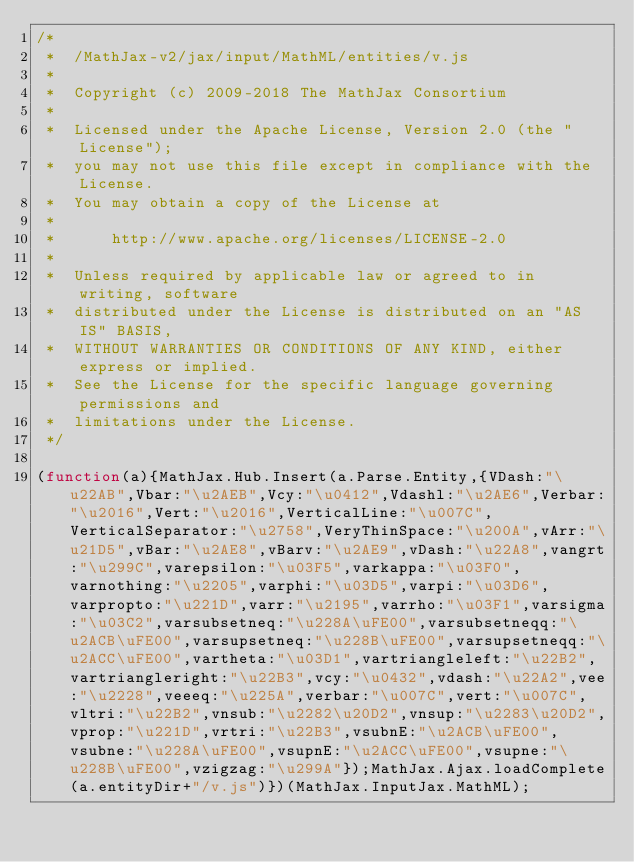Convert code to text. <code><loc_0><loc_0><loc_500><loc_500><_JavaScript_>/*
 *  /MathJax-v2/jax/input/MathML/entities/v.js
 *
 *  Copyright (c) 2009-2018 The MathJax Consortium
 *
 *  Licensed under the Apache License, Version 2.0 (the "License");
 *  you may not use this file except in compliance with the License.
 *  You may obtain a copy of the License at
 *
 *      http://www.apache.org/licenses/LICENSE-2.0
 *
 *  Unless required by applicable law or agreed to in writing, software
 *  distributed under the License is distributed on an "AS IS" BASIS,
 *  WITHOUT WARRANTIES OR CONDITIONS OF ANY KIND, either express or implied.
 *  See the License for the specific language governing permissions and
 *  limitations under the License.
 */

(function(a){MathJax.Hub.Insert(a.Parse.Entity,{VDash:"\u22AB",Vbar:"\u2AEB",Vcy:"\u0412",Vdashl:"\u2AE6",Verbar:"\u2016",Vert:"\u2016",VerticalLine:"\u007C",VerticalSeparator:"\u2758",VeryThinSpace:"\u200A",vArr:"\u21D5",vBar:"\u2AE8",vBarv:"\u2AE9",vDash:"\u22A8",vangrt:"\u299C",varepsilon:"\u03F5",varkappa:"\u03F0",varnothing:"\u2205",varphi:"\u03D5",varpi:"\u03D6",varpropto:"\u221D",varr:"\u2195",varrho:"\u03F1",varsigma:"\u03C2",varsubsetneq:"\u228A\uFE00",varsubsetneqq:"\u2ACB\uFE00",varsupsetneq:"\u228B\uFE00",varsupsetneqq:"\u2ACC\uFE00",vartheta:"\u03D1",vartriangleleft:"\u22B2",vartriangleright:"\u22B3",vcy:"\u0432",vdash:"\u22A2",vee:"\u2228",veeeq:"\u225A",verbar:"\u007C",vert:"\u007C",vltri:"\u22B2",vnsub:"\u2282\u20D2",vnsup:"\u2283\u20D2",vprop:"\u221D",vrtri:"\u22B3",vsubnE:"\u2ACB\uFE00",vsubne:"\u228A\uFE00",vsupnE:"\u2ACC\uFE00",vsupne:"\u228B\uFE00",vzigzag:"\u299A"});MathJax.Ajax.loadComplete(a.entityDir+"/v.js")})(MathJax.InputJax.MathML);
</code> 